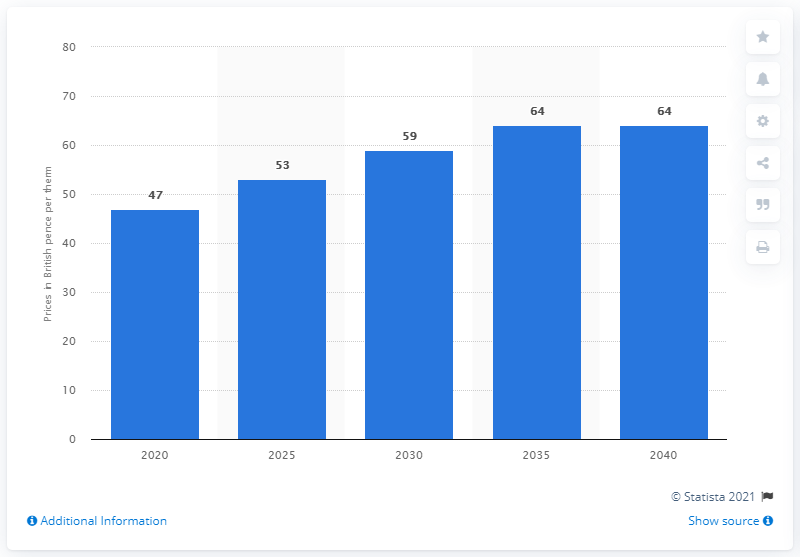Highlight a few significant elements in this photo. The wholesale price for natural gas in the UK is currently 47... 